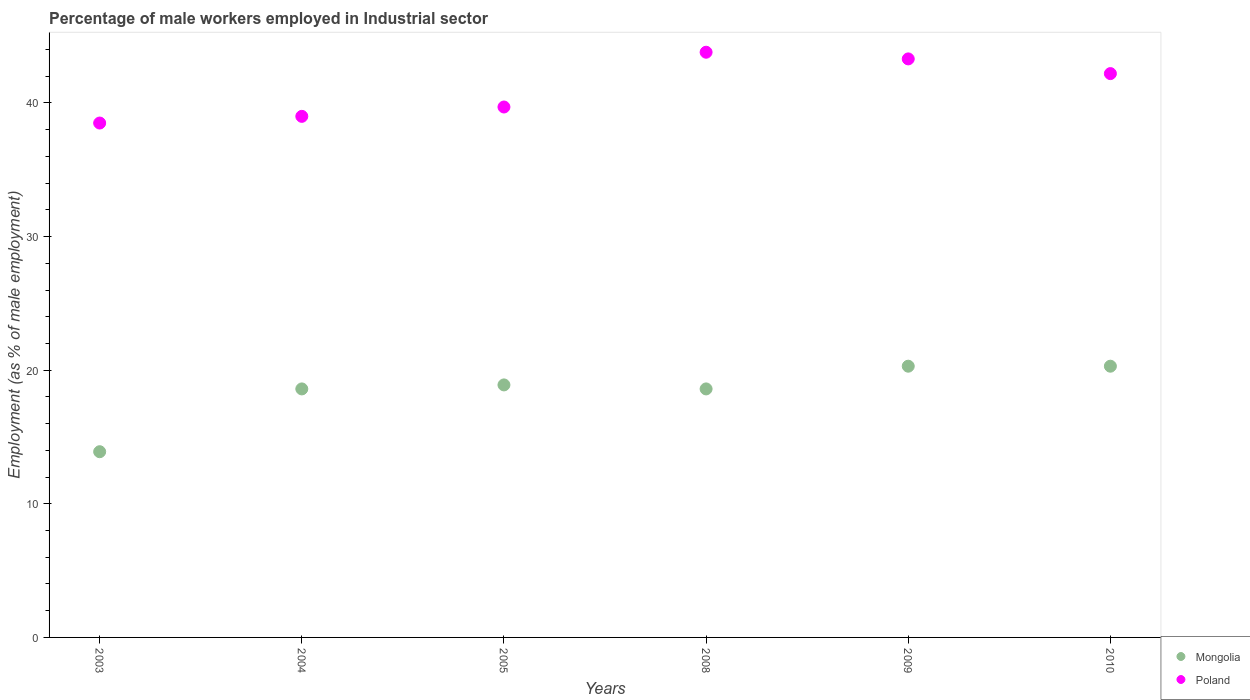How many different coloured dotlines are there?
Keep it short and to the point. 2. Is the number of dotlines equal to the number of legend labels?
Your answer should be compact. Yes. What is the percentage of male workers employed in Industrial sector in Poland in 2009?
Provide a short and direct response. 43.3. Across all years, what is the maximum percentage of male workers employed in Industrial sector in Poland?
Ensure brevity in your answer.  43.8. Across all years, what is the minimum percentage of male workers employed in Industrial sector in Poland?
Provide a succinct answer. 38.5. In which year was the percentage of male workers employed in Industrial sector in Poland maximum?
Ensure brevity in your answer.  2008. What is the total percentage of male workers employed in Industrial sector in Poland in the graph?
Give a very brief answer. 246.5. What is the difference between the percentage of male workers employed in Industrial sector in Mongolia in 2008 and that in 2010?
Your response must be concise. -1.7. What is the difference between the percentage of male workers employed in Industrial sector in Poland in 2003 and the percentage of male workers employed in Industrial sector in Mongolia in 2005?
Offer a very short reply. 19.6. What is the average percentage of male workers employed in Industrial sector in Mongolia per year?
Your response must be concise. 18.43. In the year 2010, what is the difference between the percentage of male workers employed in Industrial sector in Poland and percentage of male workers employed in Industrial sector in Mongolia?
Make the answer very short. 21.9. In how many years, is the percentage of male workers employed in Industrial sector in Poland greater than 32 %?
Ensure brevity in your answer.  6. What is the ratio of the percentage of male workers employed in Industrial sector in Mongolia in 2008 to that in 2009?
Provide a short and direct response. 0.92. Is the percentage of male workers employed in Industrial sector in Poland in 2004 less than that in 2009?
Offer a terse response. Yes. Is the difference between the percentage of male workers employed in Industrial sector in Poland in 2004 and 2008 greater than the difference between the percentage of male workers employed in Industrial sector in Mongolia in 2004 and 2008?
Offer a very short reply. No. What is the difference between the highest and the second highest percentage of male workers employed in Industrial sector in Poland?
Your response must be concise. 0.5. What is the difference between the highest and the lowest percentage of male workers employed in Industrial sector in Poland?
Offer a very short reply. 5.3. In how many years, is the percentage of male workers employed in Industrial sector in Mongolia greater than the average percentage of male workers employed in Industrial sector in Mongolia taken over all years?
Provide a short and direct response. 5. Does the percentage of male workers employed in Industrial sector in Poland monotonically increase over the years?
Provide a short and direct response. No. Is the percentage of male workers employed in Industrial sector in Poland strictly greater than the percentage of male workers employed in Industrial sector in Mongolia over the years?
Make the answer very short. Yes. How many years are there in the graph?
Offer a very short reply. 6. Are the values on the major ticks of Y-axis written in scientific E-notation?
Provide a succinct answer. No. How are the legend labels stacked?
Your answer should be very brief. Vertical. What is the title of the graph?
Provide a short and direct response. Percentage of male workers employed in Industrial sector. What is the label or title of the X-axis?
Provide a succinct answer. Years. What is the label or title of the Y-axis?
Make the answer very short. Employment (as % of male employment). What is the Employment (as % of male employment) in Mongolia in 2003?
Make the answer very short. 13.9. What is the Employment (as % of male employment) in Poland in 2003?
Offer a very short reply. 38.5. What is the Employment (as % of male employment) in Mongolia in 2004?
Your response must be concise. 18.6. What is the Employment (as % of male employment) of Poland in 2004?
Keep it short and to the point. 39. What is the Employment (as % of male employment) of Mongolia in 2005?
Your response must be concise. 18.9. What is the Employment (as % of male employment) of Poland in 2005?
Give a very brief answer. 39.7. What is the Employment (as % of male employment) of Mongolia in 2008?
Your answer should be very brief. 18.6. What is the Employment (as % of male employment) in Poland in 2008?
Make the answer very short. 43.8. What is the Employment (as % of male employment) in Mongolia in 2009?
Provide a succinct answer. 20.3. What is the Employment (as % of male employment) in Poland in 2009?
Your answer should be compact. 43.3. What is the Employment (as % of male employment) in Mongolia in 2010?
Make the answer very short. 20.3. What is the Employment (as % of male employment) of Poland in 2010?
Your answer should be compact. 42.2. Across all years, what is the maximum Employment (as % of male employment) of Mongolia?
Provide a short and direct response. 20.3. Across all years, what is the maximum Employment (as % of male employment) of Poland?
Give a very brief answer. 43.8. Across all years, what is the minimum Employment (as % of male employment) in Mongolia?
Give a very brief answer. 13.9. Across all years, what is the minimum Employment (as % of male employment) of Poland?
Your answer should be compact. 38.5. What is the total Employment (as % of male employment) in Mongolia in the graph?
Ensure brevity in your answer.  110.6. What is the total Employment (as % of male employment) of Poland in the graph?
Make the answer very short. 246.5. What is the difference between the Employment (as % of male employment) in Mongolia in 2003 and that in 2004?
Provide a succinct answer. -4.7. What is the difference between the Employment (as % of male employment) of Poland in 2003 and that in 2004?
Your response must be concise. -0.5. What is the difference between the Employment (as % of male employment) in Mongolia in 2003 and that in 2005?
Your answer should be very brief. -5. What is the difference between the Employment (as % of male employment) of Poland in 2003 and that in 2008?
Your answer should be very brief. -5.3. What is the difference between the Employment (as % of male employment) of Mongolia in 2003 and that in 2009?
Your answer should be very brief. -6.4. What is the difference between the Employment (as % of male employment) of Mongolia in 2003 and that in 2010?
Keep it short and to the point. -6.4. What is the difference between the Employment (as % of male employment) of Poland in 2003 and that in 2010?
Ensure brevity in your answer.  -3.7. What is the difference between the Employment (as % of male employment) of Mongolia in 2004 and that in 2005?
Give a very brief answer. -0.3. What is the difference between the Employment (as % of male employment) in Poland in 2004 and that in 2005?
Your response must be concise. -0.7. What is the difference between the Employment (as % of male employment) of Mongolia in 2004 and that in 2008?
Make the answer very short. 0. What is the difference between the Employment (as % of male employment) in Poland in 2004 and that in 2008?
Make the answer very short. -4.8. What is the difference between the Employment (as % of male employment) in Mongolia in 2004 and that in 2009?
Keep it short and to the point. -1.7. What is the difference between the Employment (as % of male employment) of Poland in 2004 and that in 2009?
Give a very brief answer. -4.3. What is the difference between the Employment (as % of male employment) in Poland in 2004 and that in 2010?
Keep it short and to the point. -3.2. What is the difference between the Employment (as % of male employment) of Mongolia in 2005 and that in 2009?
Your response must be concise. -1.4. What is the difference between the Employment (as % of male employment) in Poland in 2005 and that in 2009?
Keep it short and to the point. -3.6. What is the difference between the Employment (as % of male employment) in Mongolia in 2005 and that in 2010?
Keep it short and to the point. -1.4. What is the difference between the Employment (as % of male employment) in Mongolia in 2008 and that in 2009?
Provide a succinct answer. -1.7. What is the difference between the Employment (as % of male employment) in Poland in 2008 and that in 2009?
Give a very brief answer. 0.5. What is the difference between the Employment (as % of male employment) in Mongolia in 2009 and that in 2010?
Your answer should be very brief. 0. What is the difference between the Employment (as % of male employment) in Mongolia in 2003 and the Employment (as % of male employment) in Poland in 2004?
Offer a very short reply. -25.1. What is the difference between the Employment (as % of male employment) in Mongolia in 2003 and the Employment (as % of male employment) in Poland in 2005?
Your answer should be very brief. -25.8. What is the difference between the Employment (as % of male employment) in Mongolia in 2003 and the Employment (as % of male employment) in Poland in 2008?
Your answer should be compact. -29.9. What is the difference between the Employment (as % of male employment) of Mongolia in 2003 and the Employment (as % of male employment) of Poland in 2009?
Ensure brevity in your answer.  -29.4. What is the difference between the Employment (as % of male employment) of Mongolia in 2003 and the Employment (as % of male employment) of Poland in 2010?
Provide a short and direct response. -28.3. What is the difference between the Employment (as % of male employment) in Mongolia in 2004 and the Employment (as % of male employment) in Poland in 2005?
Provide a succinct answer. -21.1. What is the difference between the Employment (as % of male employment) in Mongolia in 2004 and the Employment (as % of male employment) in Poland in 2008?
Provide a succinct answer. -25.2. What is the difference between the Employment (as % of male employment) in Mongolia in 2004 and the Employment (as % of male employment) in Poland in 2009?
Your answer should be compact. -24.7. What is the difference between the Employment (as % of male employment) in Mongolia in 2004 and the Employment (as % of male employment) in Poland in 2010?
Keep it short and to the point. -23.6. What is the difference between the Employment (as % of male employment) in Mongolia in 2005 and the Employment (as % of male employment) in Poland in 2008?
Provide a short and direct response. -24.9. What is the difference between the Employment (as % of male employment) of Mongolia in 2005 and the Employment (as % of male employment) of Poland in 2009?
Your answer should be compact. -24.4. What is the difference between the Employment (as % of male employment) of Mongolia in 2005 and the Employment (as % of male employment) of Poland in 2010?
Ensure brevity in your answer.  -23.3. What is the difference between the Employment (as % of male employment) of Mongolia in 2008 and the Employment (as % of male employment) of Poland in 2009?
Your answer should be compact. -24.7. What is the difference between the Employment (as % of male employment) in Mongolia in 2008 and the Employment (as % of male employment) in Poland in 2010?
Your answer should be very brief. -23.6. What is the difference between the Employment (as % of male employment) in Mongolia in 2009 and the Employment (as % of male employment) in Poland in 2010?
Provide a succinct answer. -21.9. What is the average Employment (as % of male employment) of Mongolia per year?
Your answer should be compact. 18.43. What is the average Employment (as % of male employment) of Poland per year?
Ensure brevity in your answer.  41.08. In the year 2003, what is the difference between the Employment (as % of male employment) in Mongolia and Employment (as % of male employment) in Poland?
Your answer should be compact. -24.6. In the year 2004, what is the difference between the Employment (as % of male employment) in Mongolia and Employment (as % of male employment) in Poland?
Make the answer very short. -20.4. In the year 2005, what is the difference between the Employment (as % of male employment) of Mongolia and Employment (as % of male employment) of Poland?
Give a very brief answer. -20.8. In the year 2008, what is the difference between the Employment (as % of male employment) of Mongolia and Employment (as % of male employment) of Poland?
Keep it short and to the point. -25.2. In the year 2009, what is the difference between the Employment (as % of male employment) of Mongolia and Employment (as % of male employment) of Poland?
Your answer should be compact. -23. In the year 2010, what is the difference between the Employment (as % of male employment) of Mongolia and Employment (as % of male employment) of Poland?
Keep it short and to the point. -21.9. What is the ratio of the Employment (as % of male employment) in Mongolia in 2003 to that in 2004?
Your answer should be compact. 0.75. What is the ratio of the Employment (as % of male employment) in Poland in 2003 to that in 2004?
Offer a terse response. 0.99. What is the ratio of the Employment (as % of male employment) in Mongolia in 2003 to that in 2005?
Provide a succinct answer. 0.74. What is the ratio of the Employment (as % of male employment) of Poland in 2003 to that in 2005?
Give a very brief answer. 0.97. What is the ratio of the Employment (as % of male employment) in Mongolia in 2003 to that in 2008?
Make the answer very short. 0.75. What is the ratio of the Employment (as % of male employment) in Poland in 2003 to that in 2008?
Make the answer very short. 0.88. What is the ratio of the Employment (as % of male employment) of Mongolia in 2003 to that in 2009?
Provide a succinct answer. 0.68. What is the ratio of the Employment (as % of male employment) of Poland in 2003 to that in 2009?
Keep it short and to the point. 0.89. What is the ratio of the Employment (as % of male employment) of Mongolia in 2003 to that in 2010?
Provide a short and direct response. 0.68. What is the ratio of the Employment (as % of male employment) in Poland in 2003 to that in 2010?
Ensure brevity in your answer.  0.91. What is the ratio of the Employment (as % of male employment) in Mongolia in 2004 to that in 2005?
Ensure brevity in your answer.  0.98. What is the ratio of the Employment (as % of male employment) in Poland in 2004 to that in 2005?
Keep it short and to the point. 0.98. What is the ratio of the Employment (as % of male employment) in Poland in 2004 to that in 2008?
Keep it short and to the point. 0.89. What is the ratio of the Employment (as % of male employment) of Mongolia in 2004 to that in 2009?
Your response must be concise. 0.92. What is the ratio of the Employment (as % of male employment) in Poland in 2004 to that in 2009?
Ensure brevity in your answer.  0.9. What is the ratio of the Employment (as % of male employment) in Mongolia in 2004 to that in 2010?
Your answer should be very brief. 0.92. What is the ratio of the Employment (as % of male employment) of Poland in 2004 to that in 2010?
Ensure brevity in your answer.  0.92. What is the ratio of the Employment (as % of male employment) of Mongolia in 2005 to that in 2008?
Your answer should be very brief. 1.02. What is the ratio of the Employment (as % of male employment) in Poland in 2005 to that in 2008?
Keep it short and to the point. 0.91. What is the ratio of the Employment (as % of male employment) of Poland in 2005 to that in 2009?
Make the answer very short. 0.92. What is the ratio of the Employment (as % of male employment) in Mongolia in 2005 to that in 2010?
Your answer should be very brief. 0.93. What is the ratio of the Employment (as % of male employment) of Poland in 2005 to that in 2010?
Ensure brevity in your answer.  0.94. What is the ratio of the Employment (as % of male employment) in Mongolia in 2008 to that in 2009?
Your response must be concise. 0.92. What is the ratio of the Employment (as % of male employment) in Poland in 2008 to that in 2009?
Offer a terse response. 1.01. What is the ratio of the Employment (as % of male employment) in Mongolia in 2008 to that in 2010?
Give a very brief answer. 0.92. What is the ratio of the Employment (as % of male employment) in Poland in 2008 to that in 2010?
Keep it short and to the point. 1.04. What is the ratio of the Employment (as % of male employment) in Mongolia in 2009 to that in 2010?
Ensure brevity in your answer.  1. What is the ratio of the Employment (as % of male employment) of Poland in 2009 to that in 2010?
Provide a succinct answer. 1.03. What is the difference between the highest and the second highest Employment (as % of male employment) of Poland?
Your answer should be compact. 0.5. What is the difference between the highest and the lowest Employment (as % of male employment) of Mongolia?
Keep it short and to the point. 6.4. What is the difference between the highest and the lowest Employment (as % of male employment) in Poland?
Keep it short and to the point. 5.3. 